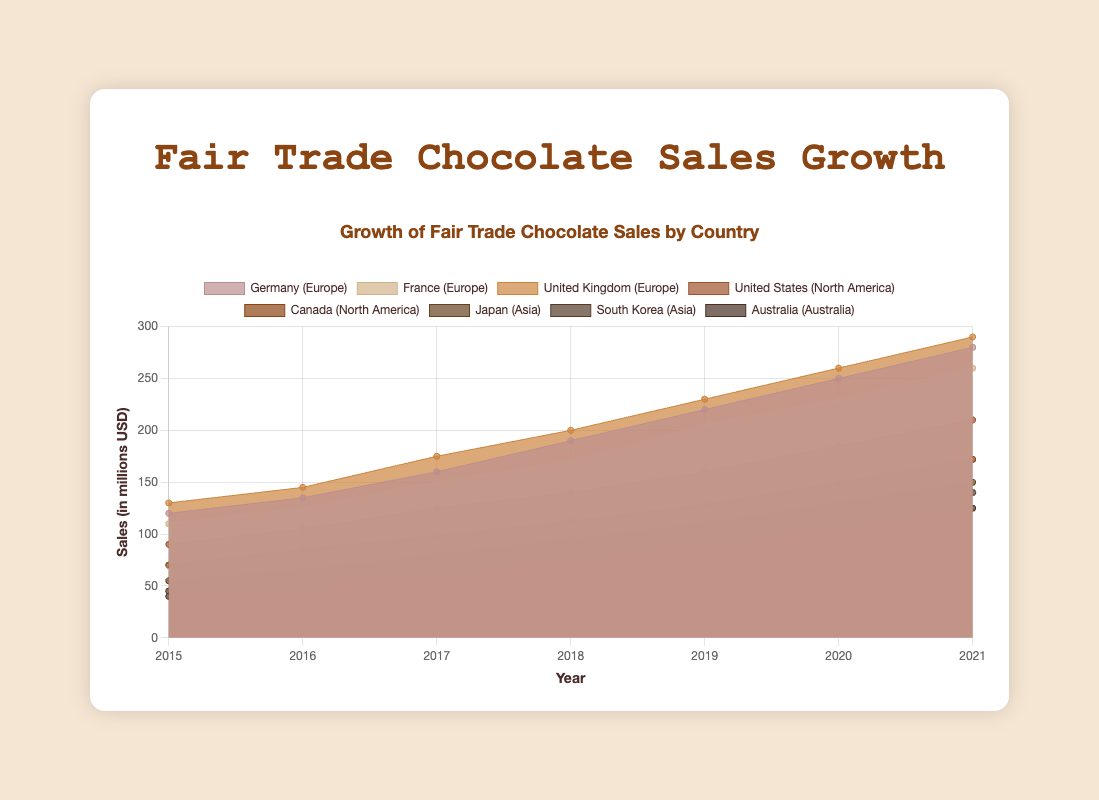What is the title of the figure? The title is typically displayed at the top of the figure. By reading it, you can identify the main subject of the chart.
Answer: Fair Trade Chocolate Sales Growth Which year shows the highest sales for Germany? By observing the Germany data line on the chart and identifying the peak value, you can find the year corresponding to the highest point.
Answer: 2021 What is the pattern of sales growth in Japan from 2015 to 2021? Look at the labeled line for Japan and follow its trajectory from 2015 to 2021. Note how the sales values change over the years.
Answer: Increasing steadily Compare the sales growth trends between the United Kingdom and France. Identify the lines for the United Kingdom and France, then compare their slopes and values over the years to see which grows faster.
Answer: United Kingdom grows faster Which country has the lowest sales in 2021? Look at the 2021 data points for all countries and identify the one with the smallest value.
Answer: Australia What is the total sales growth in North America from 2015 to 2021? Sum the values for the United States and Canada for each year from 2015 to 2021, then add these sums together.
Answer: 313 million USD What was the difference in sales between 'Germany' and 'Australia' in 2019? Find the sales values for Germany and Australia in 2019, then subtract Australia's sales from Germany's sales.
Answer: 130 million USD Which continent shows the most consistent growth trend? By looking at the overall trends in each continent, determine which one has the least fluctuations in growth.
Answer: Asia What is the observed trend for fair trade chocolate sales globally from 2015 to 2021? Consider the collective trends of all continents and countries to summarize the overall pattern for global sales.
Answer: Increasing trend Are there any countries where sales decreased at any point from 2015 to 2021? Review the lines for each country and check if there are any segments where sales dip compared to the previous year.
Answer: No 